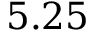Convert formula to latex. <formula><loc_0><loc_0><loc_500><loc_500>5 . 2 5</formula> 